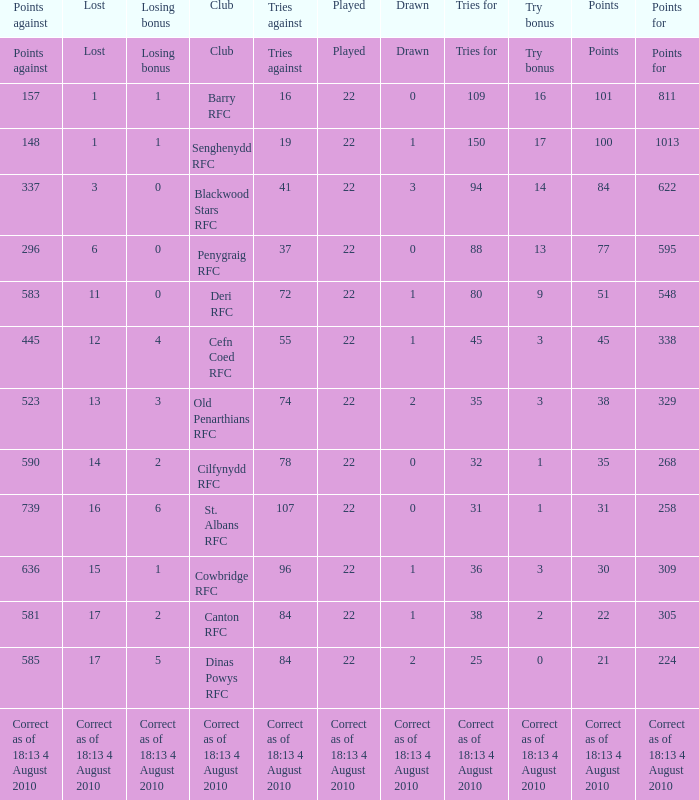What is the total number of games played when attempts against are 84, and draws are 2? 22.0. 